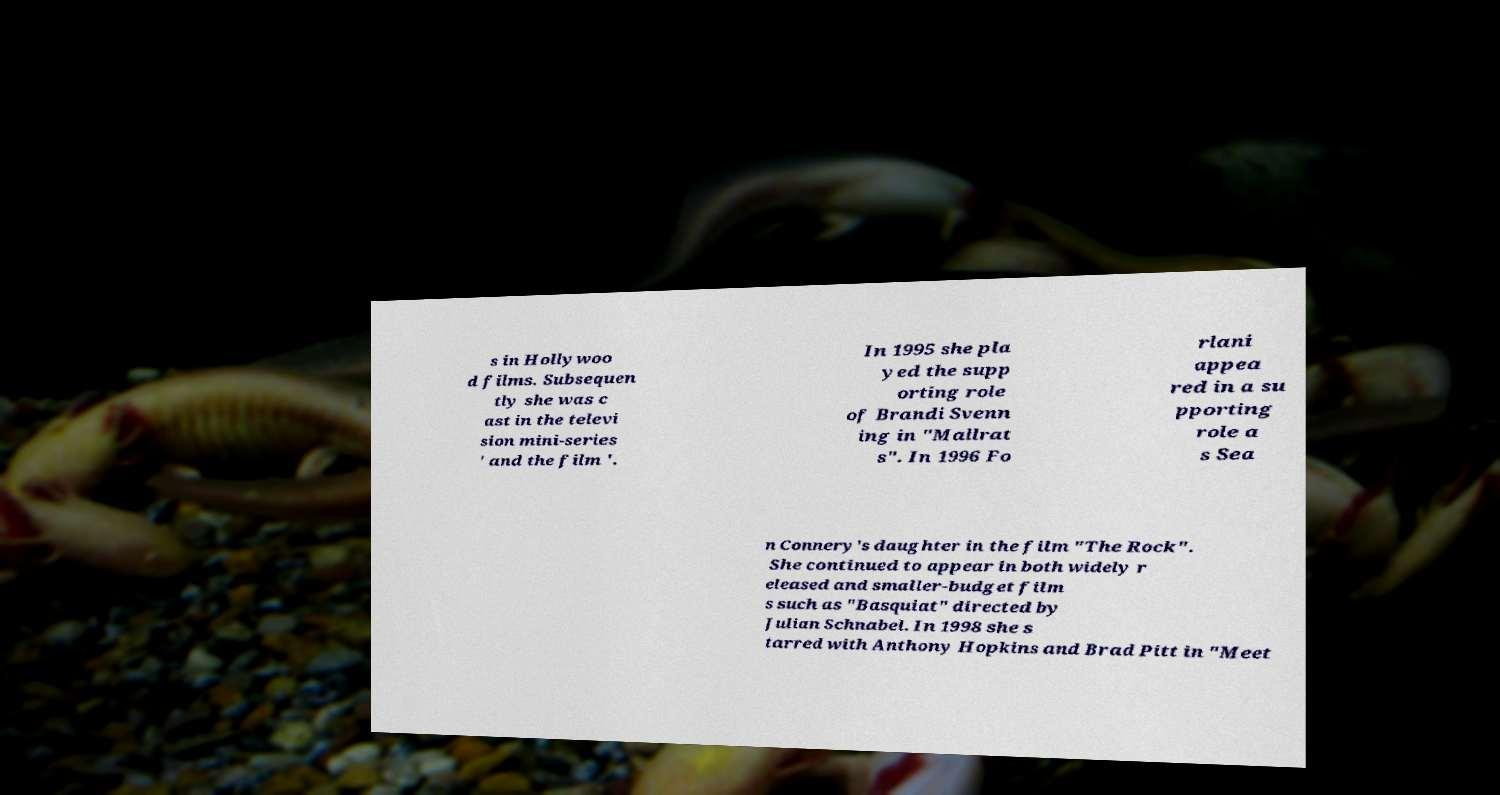Could you assist in decoding the text presented in this image and type it out clearly? s in Hollywoo d films. Subsequen tly she was c ast in the televi sion mini-series ' and the film '. In 1995 she pla yed the supp orting role of Brandi Svenn ing in "Mallrat s". In 1996 Fo rlani appea red in a su pporting role a s Sea n Connery's daughter in the film "The Rock". She continued to appear in both widely r eleased and smaller-budget film s such as "Basquiat" directed by Julian Schnabel. In 1998 she s tarred with Anthony Hopkins and Brad Pitt in "Meet 